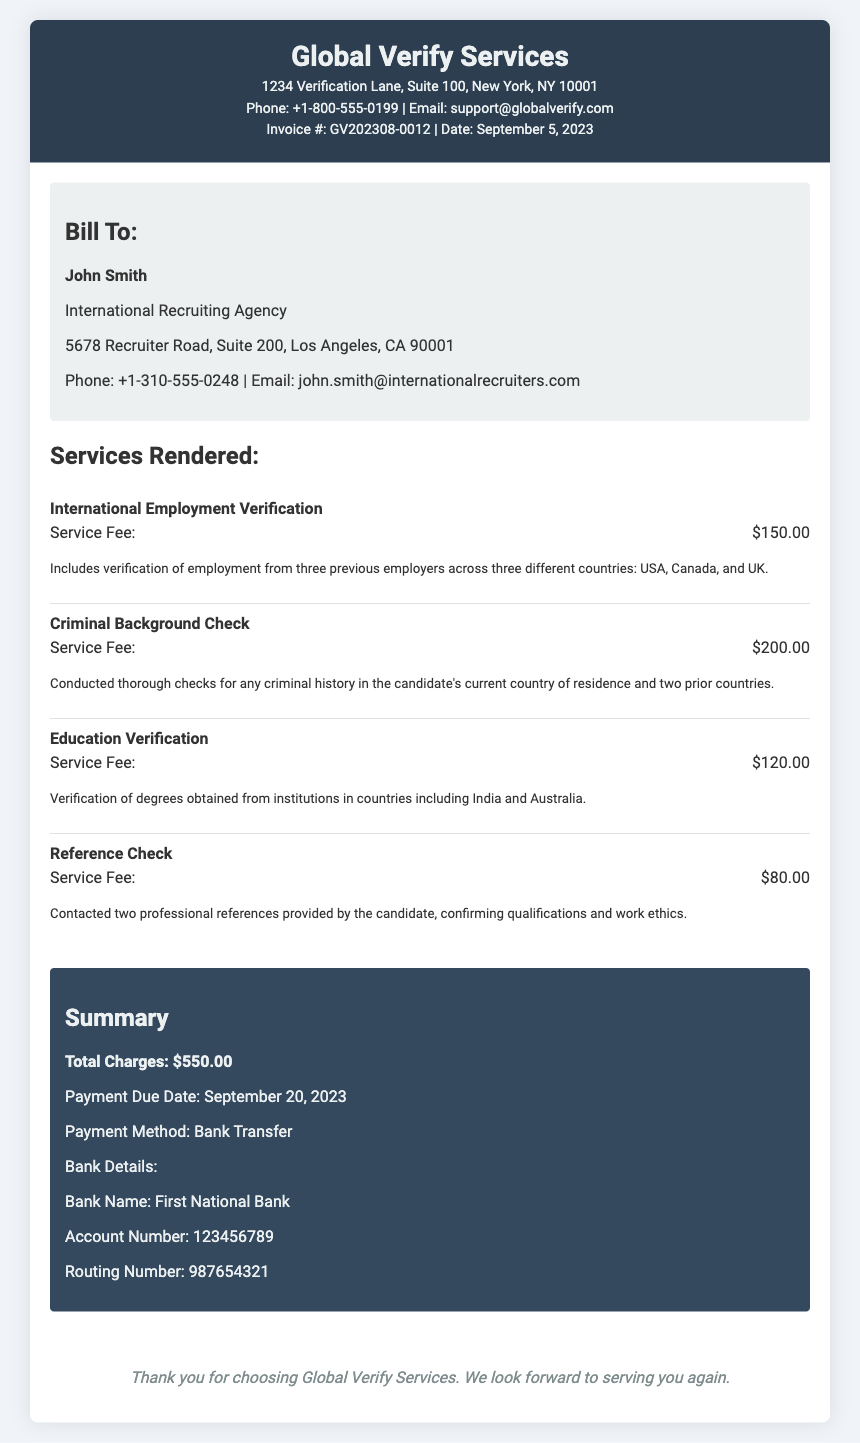What is the invoice number? The invoice number is listed in the document, which is GV202308-0012.
Answer: GV202308-0012 What is the date of the invoice? The date of the invoice is specified as September 5, 2023.
Answer: September 5, 2023 Who is the bill to? The Bill To section contains the name of the person or organization billed, which is John Smith.
Answer: John Smith What is the service fee for the Criminal Background Check? The service fee for the Criminal Background Check is provided in the services rendered section, which is $200.00.
Answer: $200.00 What is the total charge for all services? The total charge appears in the summary section, which is $550.00.
Answer: $550.00 When is the payment due date? The payment due date is mentioned in the summary section as September 20, 2023.
Answer: September 20, 2023 What payment method is specified? The document states that the payment method is Bank Transfer.
Answer: Bank Transfer How many professional references were checked? The document mentions that two professional references were contacted.
Answer: Two What is the bank name for the payment? The bank name is provided in the payment section, which is First National Bank.
Answer: First National Bank 